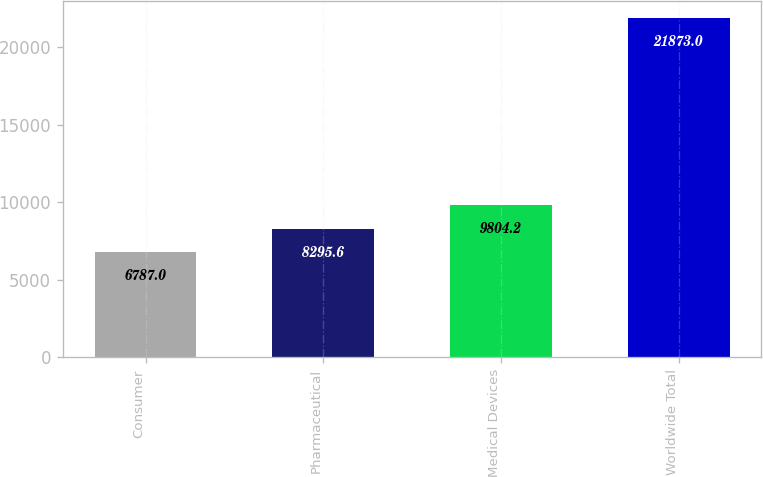Convert chart. <chart><loc_0><loc_0><loc_500><loc_500><bar_chart><fcel>Consumer<fcel>Pharmaceutical<fcel>Medical Devices<fcel>Worldwide Total<nl><fcel>6787<fcel>8295.6<fcel>9804.2<fcel>21873<nl></chart> 